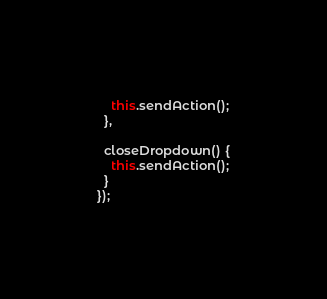<code> <loc_0><loc_0><loc_500><loc_500><_JavaScript_>    this.sendAction();
  },

  closeDropdown() {
    this.sendAction();
  }
});
</code> 